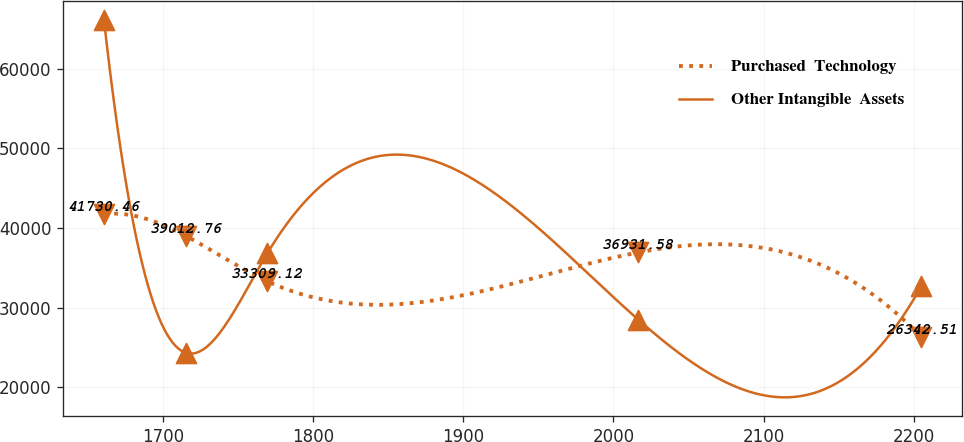Convert chart to OTSL. <chart><loc_0><loc_0><loc_500><loc_500><line_chart><ecel><fcel>Purchased  Technology<fcel>Other Intangible  Assets<nl><fcel>1660.88<fcel>41730.5<fcel>66052.9<nl><fcel>1715.3<fcel>39012.8<fcel>24352.5<nl><fcel>1769.72<fcel>33309.1<fcel>36862.6<nl><fcel>2016.51<fcel>36931.6<fcel>28522.5<nl><fcel>2205.06<fcel>26342.5<fcel>32692.6<nl></chart> 